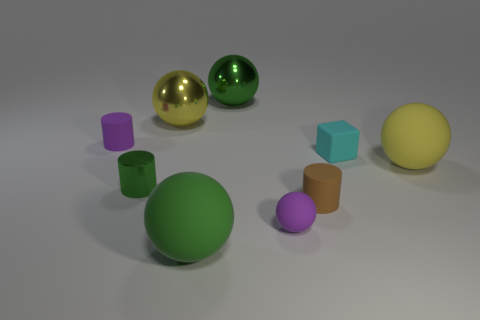Is the number of big matte balls in front of the tiny purple rubber ball the same as the number of small green matte cylinders?
Your answer should be compact. No. How many small purple cylinders are left of the yellow object that is on the right side of the large yellow thing on the left side of the cyan block?
Keep it short and to the point. 1. There is a matte cylinder that is right of the green matte sphere; what color is it?
Provide a short and direct response. Brown. The tiny cylinder that is both in front of the large yellow rubber thing and behind the tiny brown cylinder is made of what material?
Give a very brief answer. Metal. What number of yellow rubber spheres are behind the matte sphere that is right of the small cyan matte thing?
Keep it short and to the point. 0. What shape is the brown matte object?
Your answer should be compact. Cylinder. What is the shape of the yellow object that is made of the same material as the small green thing?
Keep it short and to the point. Sphere. There is a large yellow object on the left side of the green matte object; is its shape the same as the small cyan thing?
Provide a succinct answer. No. There is a green object in front of the shiny cylinder; what is its shape?
Provide a short and direct response. Sphere. The small rubber object that is the same color as the small matte sphere is what shape?
Keep it short and to the point. Cylinder. 